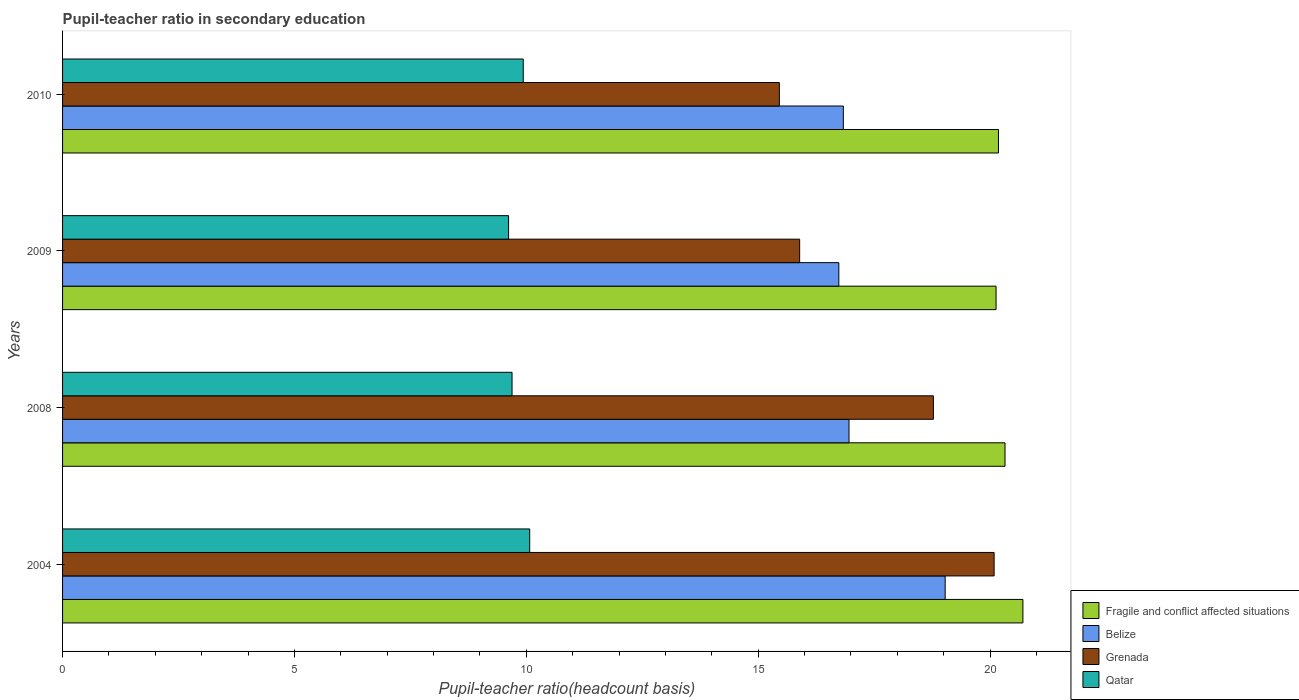How many different coloured bars are there?
Provide a succinct answer. 4. Are the number of bars per tick equal to the number of legend labels?
Offer a very short reply. Yes. Are the number of bars on each tick of the Y-axis equal?
Your response must be concise. Yes. What is the label of the 2nd group of bars from the top?
Your answer should be very brief. 2009. What is the pupil-teacher ratio in secondary education in Belize in 2008?
Provide a short and direct response. 16.96. Across all years, what is the maximum pupil-teacher ratio in secondary education in Qatar?
Provide a succinct answer. 10.07. Across all years, what is the minimum pupil-teacher ratio in secondary education in Fragile and conflict affected situations?
Give a very brief answer. 20.13. In which year was the pupil-teacher ratio in secondary education in Grenada maximum?
Provide a succinct answer. 2004. What is the total pupil-teacher ratio in secondary education in Grenada in the graph?
Ensure brevity in your answer.  70.22. What is the difference between the pupil-teacher ratio in secondary education in Fragile and conflict affected situations in 2004 and that in 2010?
Ensure brevity in your answer.  0.53. What is the difference between the pupil-teacher ratio in secondary education in Fragile and conflict affected situations in 2004 and the pupil-teacher ratio in secondary education in Qatar in 2008?
Your answer should be compact. 11.02. What is the average pupil-teacher ratio in secondary education in Grenada per year?
Provide a short and direct response. 17.55. In the year 2010, what is the difference between the pupil-teacher ratio in secondary education in Grenada and pupil-teacher ratio in secondary education in Qatar?
Keep it short and to the point. 5.52. What is the ratio of the pupil-teacher ratio in secondary education in Belize in 2009 to that in 2010?
Your response must be concise. 0.99. Is the difference between the pupil-teacher ratio in secondary education in Grenada in 2008 and 2009 greater than the difference between the pupil-teacher ratio in secondary education in Qatar in 2008 and 2009?
Offer a very short reply. Yes. What is the difference between the highest and the second highest pupil-teacher ratio in secondary education in Grenada?
Give a very brief answer. 1.31. What is the difference between the highest and the lowest pupil-teacher ratio in secondary education in Belize?
Make the answer very short. 2.29. In how many years, is the pupil-teacher ratio in secondary education in Qatar greater than the average pupil-teacher ratio in secondary education in Qatar taken over all years?
Give a very brief answer. 2. What does the 2nd bar from the top in 2010 represents?
Offer a terse response. Grenada. What does the 2nd bar from the bottom in 2004 represents?
Your response must be concise. Belize. Is it the case that in every year, the sum of the pupil-teacher ratio in secondary education in Belize and pupil-teacher ratio in secondary education in Qatar is greater than the pupil-teacher ratio in secondary education in Fragile and conflict affected situations?
Offer a terse response. Yes. How many bars are there?
Keep it short and to the point. 16. What is the difference between two consecutive major ticks on the X-axis?
Your answer should be compact. 5. Are the values on the major ticks of X-axis written in scientific E-notation?
Give a very brief answer. No. What is the title of the graph?
Your response must be concise. Pupil-teacher ratio in secondary education. Does "Guatemala" appear as one of the legend labels in the graph?
Your answer should be very brief. No. What is the label or title of the X-axis?
Ensure brevity in your answer.  Pupil-teacher ratio(headcount basis). What is the label or title of the Y-axis?
Provide a short and direct response. Years. What is the Pupil-teacher ratio(headcount basis) in Fragile and conflict affected situations in 2004?
Give a very brief answer. 20.71. What is the Pupil-teacher ratio(headcount basis) in Belize in 2004?
Your response must be concise. 19.03. What is the Pupil-teacher ratio(headcount basis) in Grenada in 2004?
Your answer should be compact. 20.09. What is the Pupil-teacher ratio(headcount basis) of Qatar in 2004?
Offer a terse response. 10.07. What is the Pupil-teacher ratio(headcount basis) in Fragile and conflict affected situations in 2008?
Keep it short and to the point. 20.32. What is the Pupil-teacher ratio(headcount basis) in Belize in 2008?
Make the answer very short. 16.96. What is the Pupil-teacher ratio(headcount basis) in Grenada in 2008?
Your answer should be compact. 18.78. What is the Pupil-teacher ratio(headcount basis) in Qatar in 2008?
Ensure brevity in your answer.  9.69. What is the Pupil-teacher ratio(headcount basis) of Fragile and conflict affected situations in 2009?
Provide a short and direct response. 20.13. What is the Pupil-teacher ratio(headcount basis) in Belize in 2009?
Provide a succinct answer. 16.74. What is the Pupil-teacher ratio(headcount basis) in Grenada in 2009?
Offer a terse response. 15.89. What is the Pupil-teacher ratio(headcount basis) in Qatar in 2009?
Make the answer very short. 9.62. What is the Pupil-teacher ratio(headcount basis) in Fragile and conflict affected situations in 2010?
Offer a very short reply. 20.18. What is the Pupil-teacher ratio(headcount basis) in Belize in 2010?
Keep it short and to the point. 16.84. What is the Pupil-teacher ratio(headcount basis) in Grenada in 2010?
Your answer should be very brief. 15.46. What is the Pupil-teacher ratio(headcount basis) in Qatar in 2010?
Ensure brevity in your answer.  9.93. Across all years, what is the maximum Pupil-teacher ratio(headcount basis) in Fragile and conflict affected situations?
Make the answer very short. 20.71. Across all years, what is the maximum Pupil-teacher ratio(headcount basis) in Belize?
Your answer should be very brief. 19.03. Across all years, what is the maximum Pupil-teacher ratio(headcount basis) of Grenada?
Provide a short and direct response. 20.09. Across all years, what is the maximum Pupil-teacher ratio(headcount basis) of Qatar?
Provide a succinct answer. 10.07. Across all years, what is the minimum Pupil-teacher ratio(headcount basis) in Fragile and conflict affected situations?
Ensure brevity in your answer.  20.13. Across all years, what is the minimum Pupil-teacher ratio(headcount basis) in Belize?
Keep it short and to the point. 16.74. Across all years, what is the minimum Pupil-teacher ratio(headcount basis) in Grenada?
Offer a terse response. 15.46. Across all years, what is the minimum Pupil-teacher ratio(headcount basis) of Qatar?
Keep it short and to the point. 9.62. What is the total Pupil-teacher ratio(headcount basis) in Fragile and conflict affected situations in the graph?
Your answer should be compact. 81.34. What is the total Pupil-teacher ratio(headcount basis) in Belize in the graph?
Give a very brief answer. 69.57. What is the total Pupil-teacher ratio(headcount basis) in Grenada in the graph?
Ensure brevity in your answer.  70.22. What is the total Pupil-teacher ratio(headcount basis) in Qatar in the graph?
Your response must be concise. 39.32. What is the difference between the Pupil-teacher ratio(headcount basis) of Fragile and conflict affected situations in 2004 and that in 2008?
Your answer should be compact. 0.39. What is the difference between the Pupil-teacher ratio(headcount basis) of Belize in 2004 and that in 2008?
Offer a terse response. 2.07. What is the difference between the Pupil-teacher ratio(headcount basis) of Grenada in 2004 and that in 2008?
Ensure brevity in your answer.  1.31. What is the difference between the Pupil-teacher ratio(headcount basis) in Qatar in 2004 and that in 2008?
Give a very brief answer. 0.38. What is the difference between the Pupil-teacher ratio(headcount basis) of Fragile and conflict affected situations in 2004 and that in 2009?
Your response must be concise. 0.58. What is the difference between the Pupil-teacher ratio(headcount basis) in Belize in 2004 and that in 2009?
Your response must be concise. 2.29. What is the difference between the Pupil-teacher ratio(headcount basis) of Grenada in 2004 and that in 2009?
Keep it short and to the point. 4.19. What is the difference between the Pupil-teacher ratio(headcount basis) of Qatar in 2004 and that in 2009?
Ensure brevity in your answer.  0.46. What is the difference between the Pupil-teacher ratio(headcount basis) in Fragile and conflict affected situations in 2004 and that in 2010?
Your answer should be very brief. 0.53. What is the difference between the Pupil-teacher ratio(headcount basis) of Belize in 2004 and that in 2010?
Your answer should be compact. 2.2. What is the difference between the Pupil-teacher ratio(headcount basis) in Grenada in 2004 and that in 2010?
Ensure brevity in your answer.  4.63. What is the difference between the Pupil-teacher ratio(headcount basis) of Qatar in 2004 and that in 2010?
Provide a short and direct response. 0.14. What is the difference between the Pupil-teacher ratio(headcount basis) of Fragile and conflict affected situations in 2008 and that in 2009?
Provide a succinct answer. 0.19. What is the difference between the Pupil-teacher ratio(headcount basis) in Belize in 2008 and that in 2009?
Give a very brief answer. 0.22. What is the difference between the Pupil-teacher ratio(headcount basis) in Grenada in 2008 and that in 2009?
Offer a terse response. 2.88. What is the difference between the Pupil-teacher ratio(headcount basis) in Qatar in 2008 and that in 2009?
Make the answer very short. 0.07. What is the difference between the Pupil-teacher ratio(headcount basis) in Fragile and conflict affected situations in 2008 and that in 2010?
Your response must be concise. 0.14. What is the difference between the Pupil-teacher ratio(headcount basis) of Belize in 2008 and that in 2010?
Provide a short and direct response. 0.12. What is the difference between the Pupil-teacher ratio(headcount basis) of Grenada in 2008 and that in 2010?
Make the answer very short. 3.32. What is the difference between the Pupil-teacher ratio(headcount basis) of Qatar in 2008 and that in 2010?
Offer a terse response. -0.24. What is the difference between the Pupil-teacher ratio(headcount basis) of Fragile and conflict affected situations in 2009 and that in 2010?
Offer a terse response. -0.05. What is the difference between the Pupil-teacher ratio(headcount basis) in Belize in 2009 and that in 2010?
Your response must be concise. -0.1. What is the difference between the Pupil-teacher ratio(headcount basis) in Grenada in 2009 and that in 2010?
Your response must be concise. 0.44. What is the difference between the Pupil-teacher ratio(headcount basis) of Qatar in 2009 and that in 2010?
Offer a terse response. -0.32. What is the difference between the Pupil-teacher ratio(headcount basis) of Fragile and conflict affected situations in 2004 and the Pupil-teacher ratio(headcount basis) of Belize in 2008?
Your answer should be compact. 3.75. What is the difference between the Pupil-teacher ratio(headcount basis) in Fragile and conflict affected situations in 2004 and the Pupil-teacher ratio(headcount basis) in Grenada in 2008?
Provide a short and direct response. 1.93. What is the difference between the Pupil-teacher ratio(headcount basis) of Fragile and conflict affected situations in 2004 and the Pupil-teacher ratio(headcount basis) of Qatar in 2008?
Provide a short and direct response. 11.02. What is the difference between the Pupil-teacher ratio(headcount basis) of Belize in 2004 and the Pupil-teacher ratio(headcount basis) of Grenada in 2008?
Your answer should be compact. 0.25. What is the difference between the Pupil-teacher ratio(headcount basis) in Belize in 2004 and the Pupil-teacher ratio(headcount basis) in Qatar in 2008?
Offer a terse response. 9.34. What is the difference between the Pupil-teacher ratio(headcount basis) in Grenada in 2004 and the Pupil-teacher ratio(headcount basis) in Qatar in 2008?
Your answer should be very brief. 10.4. What is the difference between the Pupil-teacher ratio(headcount basis) in Fragile and conflict affected situations in 2004 and the Pupil-teacher ratio(headcount basis) in Belize in 2009?
Provide a short and direct response. 3.97. What is the difference between the Pupil-teacher ratio(headcount basis) of Fragile and conflict affected situations in 2004 and the Pupil-teacher ratio(headcount basis) of Grenada in 2009?
Offer a very short reply. 4.81. What is the difference between the Pupil-teacher ratio(headcount basis) of Fragile and conflict affected situations in 2004 and the Pupil-teacher ratio(headcount basis) of Qatar in 2009?
Your answer should be compact. 11.09. What is the difference between the Pupil-teacher ratio(headcount basis) in Belize in 2004 and the Pupil-teacher ratio(headcount basis) in Grenada in 2009?
Make the answer very short. 3.14. What is the difference between the Pupil-teacher ratio(headcount basis) in Belize in 2004 and the Pupil-teacher ratio(headcount basis) in Qatar in 2009?
Your answer should be compact. 9.41. What is the difference between the Pupil-teacher ratio(headcount basis) of Grenada in 2004 and the Pupil-teacher ratio(headcount basis) of Qatar in 2009?
Offer a terse response. 10.47. What is the difference between the Pupil-teacher ratio(headcount basis) in Fragile and conflict affected situations in 2004 and the Pupil-teacher ratio(headcount basis) in Belize in 2010?
Provide a succinct answer. 3.87. What is the difference between the Pupil-teacher ratio(headcount basis) in Fragile and conflict affected situations in 2004 and the Pupil-teacher ratio(headcount basis) in Grenada in 2010?
Provide a succinct answer. 5.25. What is the difference between the Pupil-teacher ratio(headcount basis) of Fragile and conflict affected situations in 2004 and the Pupil-teacher ratio(headcount basis) of Qatar in 2010?
Make the answer very short. 10.77. What is the difference between the Pupil-teacher ratio(headcount basis) in Belize in 2004 and the Pupil-teacher ratio(headcount basis) in Grenada in 2010?
Offer a terse response. 3.58. What is the difference between the Pupil-teacher ratio(headcount basis) in Belize in 2004 and the Pupil-teacher ratio(headcount basis) in Qatar in 2010?
Offer a very short reply. 9.1. What is the difference between the Pupil-teacher ratio(headcount basis) in Grenada in 2004 and the Pupil-teacher ratio(headcount basis) in Qatar in 2010?
Your answer should be compact. 10.15. What is the difference between the Pupil-teacher ratio(headcount basis) of Fragile and conflict affected situations in 2008 and the Pupil-teacher ratio(headcount basis) of Belize in 2009?
Your response must be concise. 3.58. What is the difference between the Pupil-teacher ratio(headcount basis) of Fragile and conflict affected situations in 2008 and the Pupil-teacher ratio(headcount basis) of Grenada in 2009?
Provide a short and direct response. 4.43. What is the difference between the Pupil-teacher ratio(headcount basis) in Fragile and conflict affected situations in 2008 and the Pupil-teacher ratio(headcount basis) in Qatar in 2009?
Your response must be concise. 10.71. What is the difference between the Pupil-teacher ratio(headcount basis) in Belize in 2008 and the Pupil-teacher ratio(headcount basis) in Grenada in 2009?
Provide a short and direct response. 1.06. What is the difference between the Pupil-teacher ratio(headcount basis) in Belize in 2008 and the Pupil-teacher ratio(headcount basis) in Qatar in 2009?
Offer a very short reply. 7.34. What is the difference between the Pupil-teacher ratio(headcount basis) in Grenada in 2008 and the Pupil-teacher ratio(headcount basis) in Qatar in 2009?
Make the answer very short. 9.16. What is the difference between the Pupil-teacher ratio(headcount basis) of Fragile and conflict affected situations in 2008 and the Pupil-teacher ratio(headcount basis) of Belize in 2010?
Provide a succinct answer. 3.49. What is the difference between the Pupil-teacher ratio(headcount basis) in Fragile and conflict affected situations in 2008 and the Pupil-teacher ratio(headcount basis) in Grenada in 2010?
Provide a short and direct response. 4.87. What is the difference between the Pupil-teacher ratio(headcount basis) of Fragile and conflict affected situations in 2008 and the Pupil-teacher ratio(headcount basis) of Qatar in 2010?
Your answer should be compact. 10.39. What is the difference between the Pupil-teacher ratio(headcount basis) of Belize in 2008 and the Pupil-teacher ratio(headcount basis) of Grenada in 2010?
Make the answer very short. 1.5. What is the difference between the Pupil-teacher ratio(headcount basis) in Belize in 2008 and the Pupil-teacher ratio(headcount basis) in Qatar in 2010?
Your response must be concise. 7.02. What is the difference between the Pupil-teacher ratio(headcount basis) of Grenada in 2008 and the Pupil-teacher ratio(headcount basis) of Qatar in 2010?
Offer a very short reply. 8.84. What is the difference between the Pupil-teacher ratio(headcount basis) of Fragile and conflict affected situations in 2009 and the Pupil-teacher ratio(headcount basis) of Belize in 2010?
Offer a terse response. 3.29. What is the difference between the Pupil-teacher ratio(headcount basis) of Fragile and conflict affected situations in 2009 and the Pupil-teacher ratio(headcount basis) of Grenada in 2010?
Offer a very short reply. 4.67. What is the difference between the Pupil-teacher ratio(headcount basis) in Fragile and conflict affected situations in 2009 and the Pupil-teacher ratio(headcount basis) in Qatar in 2010?
Give a very brief answer. 10.2. What is the difference between the Pupil-teacher ratio(headcount basis) in Belize in 2009 and the Pupil-teacher ratio(headcount basis) in Grenada in 2010?
Your answer should be compact. 1.28. What is the difference between the Pupil-teacher ratio(headcount basis) of Belize in 2009 and the Pupil-teacher ratio(headcount basis) of Qatar in 2010?
Your response must be concise. 6.8. What is the difference between the Pupil-teacher ratio(headcount basis) of Grenada in 2009 and the Pupil-teacher ratio(headcount basis) of Qatar in 2010?
Offer a very short reply. 5.96. What is the average Pupil-teacher ratio(headcount basis) of Fragile and conflict affected situations per year?
Provide a short and direct response. 20.34. What is the average Pupil-teacher ratio(headcount basis) of Belize per year?
Ensure brevity in your answer.  17.39. What is the average Pupil-teacher ratio(headcount basis) in Grenada per year?
Provide a succinct answer. 17.55. What is the average Pupil-teacher ratio(headcount basis) in Qatar per year?
Your response must be concise. 9.83. In the year 2004, what is the difference between the Pupil-teacher ratio(headcount basis) in Fragile and conflict affected situations and Pupil-teacher ratio(headcount basis) in Belize?
Offer a terse response. 1.68. In the year 2004, what is the difference between the Pupil-teacher ratio(headcount basis) in Fragile and conflict affected situations and Pupil-teacher ratio(headcount basis) in Grenada?
Make the answer very short. 0.62. In the year 2004, what is the difference between the Pupil-teacher ratio(headcount basis) in Fragile and conflict affected situations and Pupil-teacher ratio(headcount basis) in Qatar?
Your answer should be very brief. 10.64. In the year 2004, what is the difference between the Pupil-teacher ratio(headcount basis) of Belize and Pupil-teacher ratio(headcount basis) of Grenada?
Provide a short and direct response. -1.06. In the year 2004, what is the difference between the Pupil-teacher ratio(headcount basis) of Belize and Pupil-teacher ratio(headcount basis) of Qatar?
Offer a terse response. 8.96. In the year 2004, what is the difference between the Pupil-teacher ratio(headcount basis) of Grenada and Pupil-teacher ratio(headcount basis) of Qatar?
Offer a very short reply. 10.01. In the year 2008, what is the difference between the Pupil-teacher ratio(headcount basis) in Fragile and conflict affected situations and Pupil-teacher ratio(headcount basis) in Belize?
Give a very brief answer. 3.36. In the year 2008, what is the difference between the Pupil-teacher ratio(headcount basis) in Fragile and conflict affected situations and Pupil-teacher ratio(headcount basis) in Grenada?
Your answer should be compact. 1.54. In the year 2008, what is the difference between the Pupil-teacher ratio(headcount basis) in Fragile and conflict affected situations and Pupil-teacher ratio(headcount basis) in Qatar?
Keep it short and to the point. 10.63. In the year 2008, what is the difference between the Pupil-teacher ratio(headcount basis) in Belize and Pupil-teacher ratio(headcount basis) in Grenada?
Give a very brief answer. -1.82. In the year 2008, what is the difference between the Pupil-teacher ratio(headcount basis) of Belize and Pupil-teacher ratio(headcount basis) of Qatar?
Offer a terse response. 7.27. In the year 2008, what is the difference between the Pupil-teacher ratio(headcount basis) in Grenada and Pupil-teacher ratio(headcount basis) in Qatar?
Provide a short and direct response. 9.09. In the year 2009, what is the difference between the Pupil-teacher ratio(headcount basis) of Fragile and conflict affected situations and Pupil-teacher ratio(headcount basis) of Belize?
Provide a succinct answer. 3.39. In the year 2009, what is the difference between the Pupil-teacher ratio(headcount basis) of Fragile and conflict affected situations and Pupil-teacher ratio(headcount basis) of Grenada?
Your answer should be compact. 4.24. In the year 2009, what is the difference between the Pupil-teacher ratio(headcount basis) in Fragile and conflict affected situations and Pupil-teacher ratio(headcount basis) in Qatar?
Provide a succinct answer. 10.51. In the year 2009, what is the difference between the Pupil-teacher ratio(headcount basis) in Belize and Pupil-teacher ratio(headcount basis) in Grenada?
Provide a short and direct response. 0.84. In the year 2009, what is the difference between the Pupil-teacher ratio(headcount basis) of Belize and Pupil-teacher ratio(headcount basis) of Qatar?
Offer a terse response. 7.12. In the year 2009, what is the difference between the Pupil-teacher ratio(headcount basis) of Grenada and Pupil-teacher ratio(headcount basis) of Qatar?
Your answer should be compact. 6.28. In the year 2010, what is the difference between the Pupil-teacher ratio(headcount basis) in Fragile and conflict affected situations and Pupil-teacher ratio(headcount basis) in Belize?
Offer a terse response. 3.35. In the year 2010, what is the difference between the Pupil-teacher ratio(headcount basis) of Fragile and conflict affected situations and Pupil-teacher ratio(headcount basis) of Grenada?
Your answer should be compact. 4.72. In the year 2010, what is the difference between the Pupil-teacher ratio(headcount basis) in Fragile and conflict affected situations and Pupil-teacher ratio(headcount basis) in Qatar?
Ensure brevity in your answer.  10.25. In the year 2010, what is the difference between the Pupil-teacher ratio(headcount basis) in Belize and Pupil-teacher ratio(headcount basis) in Grenada?
Offer a very short reply. 1.38. In the year 2010, what is the difference between the Pupil-teacher ratio(headcount basis) in Belize and Pupil-teacher ratio(headcount basis) in Qatar?
Your answer should be very brief. 6.9. In the year 2010, what is the difference between the Pupil-teacher ratio(headcount basis) of Grenada and Pupil-teacher ratio(headcount basis) of Qatar?
Provide a short and direct response. 5.52. What is the ratio of the Pupil-teacher ratio(headcount basis) of Belize in 2004 to that in 2008?
Keep it short and to the point. 1.12. What is the ratio of the Pupil-teacher ratio(headcount basis) of Grenada in 2004 to that in 2008?
Offer a terse response. 1.07. What is the ratio of the Pupil-teacher ratio(headcount basis) in Qatar in 2004 to that in 2008?
Keep it short and to the point. 1.04. What is the ratio of the Pupil-teacher ratio(headcount basis) of Fragile and conflict affected situations in 2004 to that in 2009?
Provide a succinct answer. 1.03. What is the ratio of the Pupil-teacher ratio(headcount basis) in Belize in 2004 to that in 2009?
Provide a succinct answer. 1.14. What is the ratio of the Pupil-teacher ratio(headcount basis) of Grenada in 2004 to that in 2009?
Give a very brief answer. 1.26. What is the ratio of the Pupil-teacher ratio(headcount basis) in Qatar in 2004 to that in 2009?
Offer a terse response. 1.05. What is the ratio of the Pupil-teacher ratio(headcount basis) of Fragile and conflict affected situations in 2004 to that in 2010?
Ensure brevity in your answer.  1.03. What is the ratio of the Pupil-teacher ratio(headcount basis) in Belize in 2004 to that in 2010?
Your response must be concise. 1.13. What is the ratio of the Pupil-teacher ratio(headcount basis) in Grenada in 2004 to that in 2010?
Offer a terse response. 1.3. What is the ratio of the Pupil-teacher ratio(headcount basis) of Qatar in 2004 to that in 2010?
Ensure brevity in your answer.  1.01. What is the ratio of the Pupil-teacher ratio(headcount basis) in Fragile and conflict affected situations in 2008 to that in 2009?
Your answer should be compact. 1.01. What is the ratio of the Pupil-teacher ratio(headcount basis) of Belize in 2008 to that in 2009?
Your response must be concise. 1.01. What is the ratio of the Pupil-teacher ratio(headcount basis) of Grenada in 2008 to that in 2009?
Offer a terse response. 1.18. What is the ratio of the Pupil-teacher ratio(headcount basis) in Fragile and conflict affected situations in 2008 to that in 2010?
Your answer should be very brief. 1.01. What is the ratio of the Pupil-teacher ratio(headcount basis) in Belize in 2008 to that in 2010?
Provide a succinct answer. 1.01. What is the ratio of the Pupil-teacher ratio(headcount basis) of Grenada in 2008 to that in 2010?
Ensure brevity in your answer.  1.21. What is the ratio of the Pupil-teacher ratio(headcount basis) in Qatar in 2008 to that in 2010?
Provide a short and direct response. 0.98. What is the ratio of the Pupil-teacher ratio(headcount basis) in Grenada in 2009 to that in 2010?
Offer a terse response. 1.03. What is the ratio of the Pupil-teacher ratio(headcount basis) of Qatar in 2009 to that in 2010?
Give a very brief answer. 0.97. What is the difference between the highest and the second highest Pupil-teacher ratio(headcount basis) of Fragile and conflict affected situations?
Offer a terse response. 0.39. What is the difference between the highest and the second highest Pupil-teacher ratio(headcount basis) in Belize?
Your answer should be compact. 2.07. What is the difference between the highest and the second highest Pupil-teacher ratio(headcount basis) in Grenada?
Provide a succinct answer. 1.31. What is the difference between the highest and the second highest Pupil-teacher ratio(headcount basis) in Qatar?
Your response must be concise. 0.14. What is the difference between the highest and the lowest Pupil-teacher ratio(headcount basis) of Fragile and conflict affected situations?
Offer a terse response. 0.58. What is the difference between the highest and the lowest Pupil-teacher ratio(headcount basis) of Belize?
Give a very brief answer. 2.29. What is the difference between the highest and the lowest Pupil-teacher ratio(headcount basis) in Grenada?
Ensure brevity in your answer.  4.63. What is the difference between the highest and the lowest Pupil-teacher ratio(headcount basis) in Qatar?
Provide a short and direct response. 0.46. 